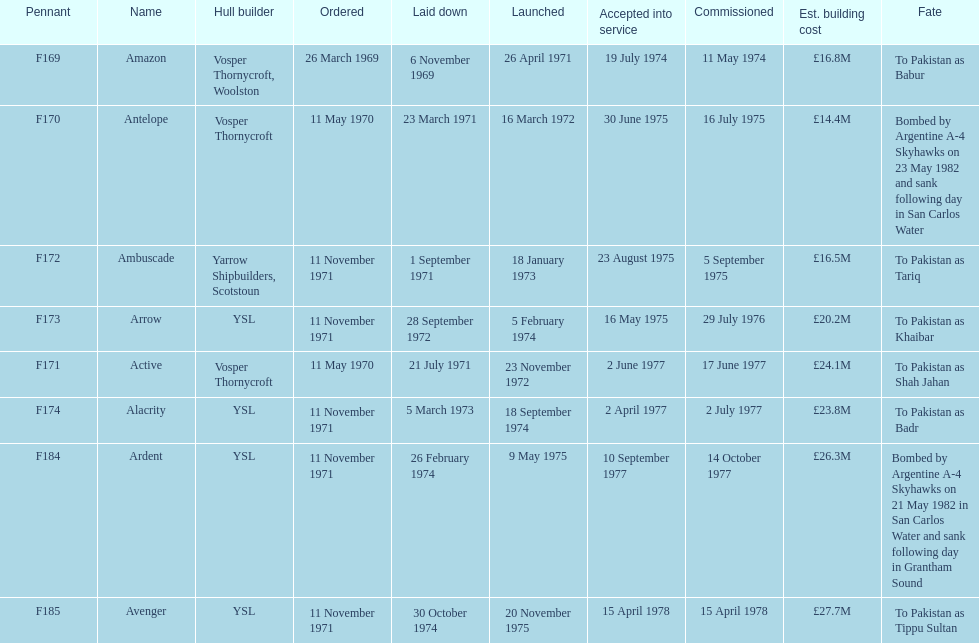Which maritime craft had the highest expected expenditure for building? Avenger. 